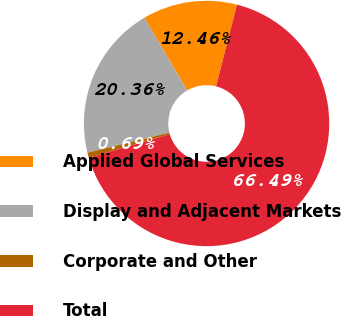Convert chart. <chart><loc_0><loc_0><loc_500><loc_500><pie_chart><fcel>Applied Global Services<fcel>Display and Adjacent Markets<fcel>Corporate and Other<fcel>Total<nl><fcel>12.46%<fcel>20.36%<fcel>0.69%<fcel>66.49%<nl></chart> 